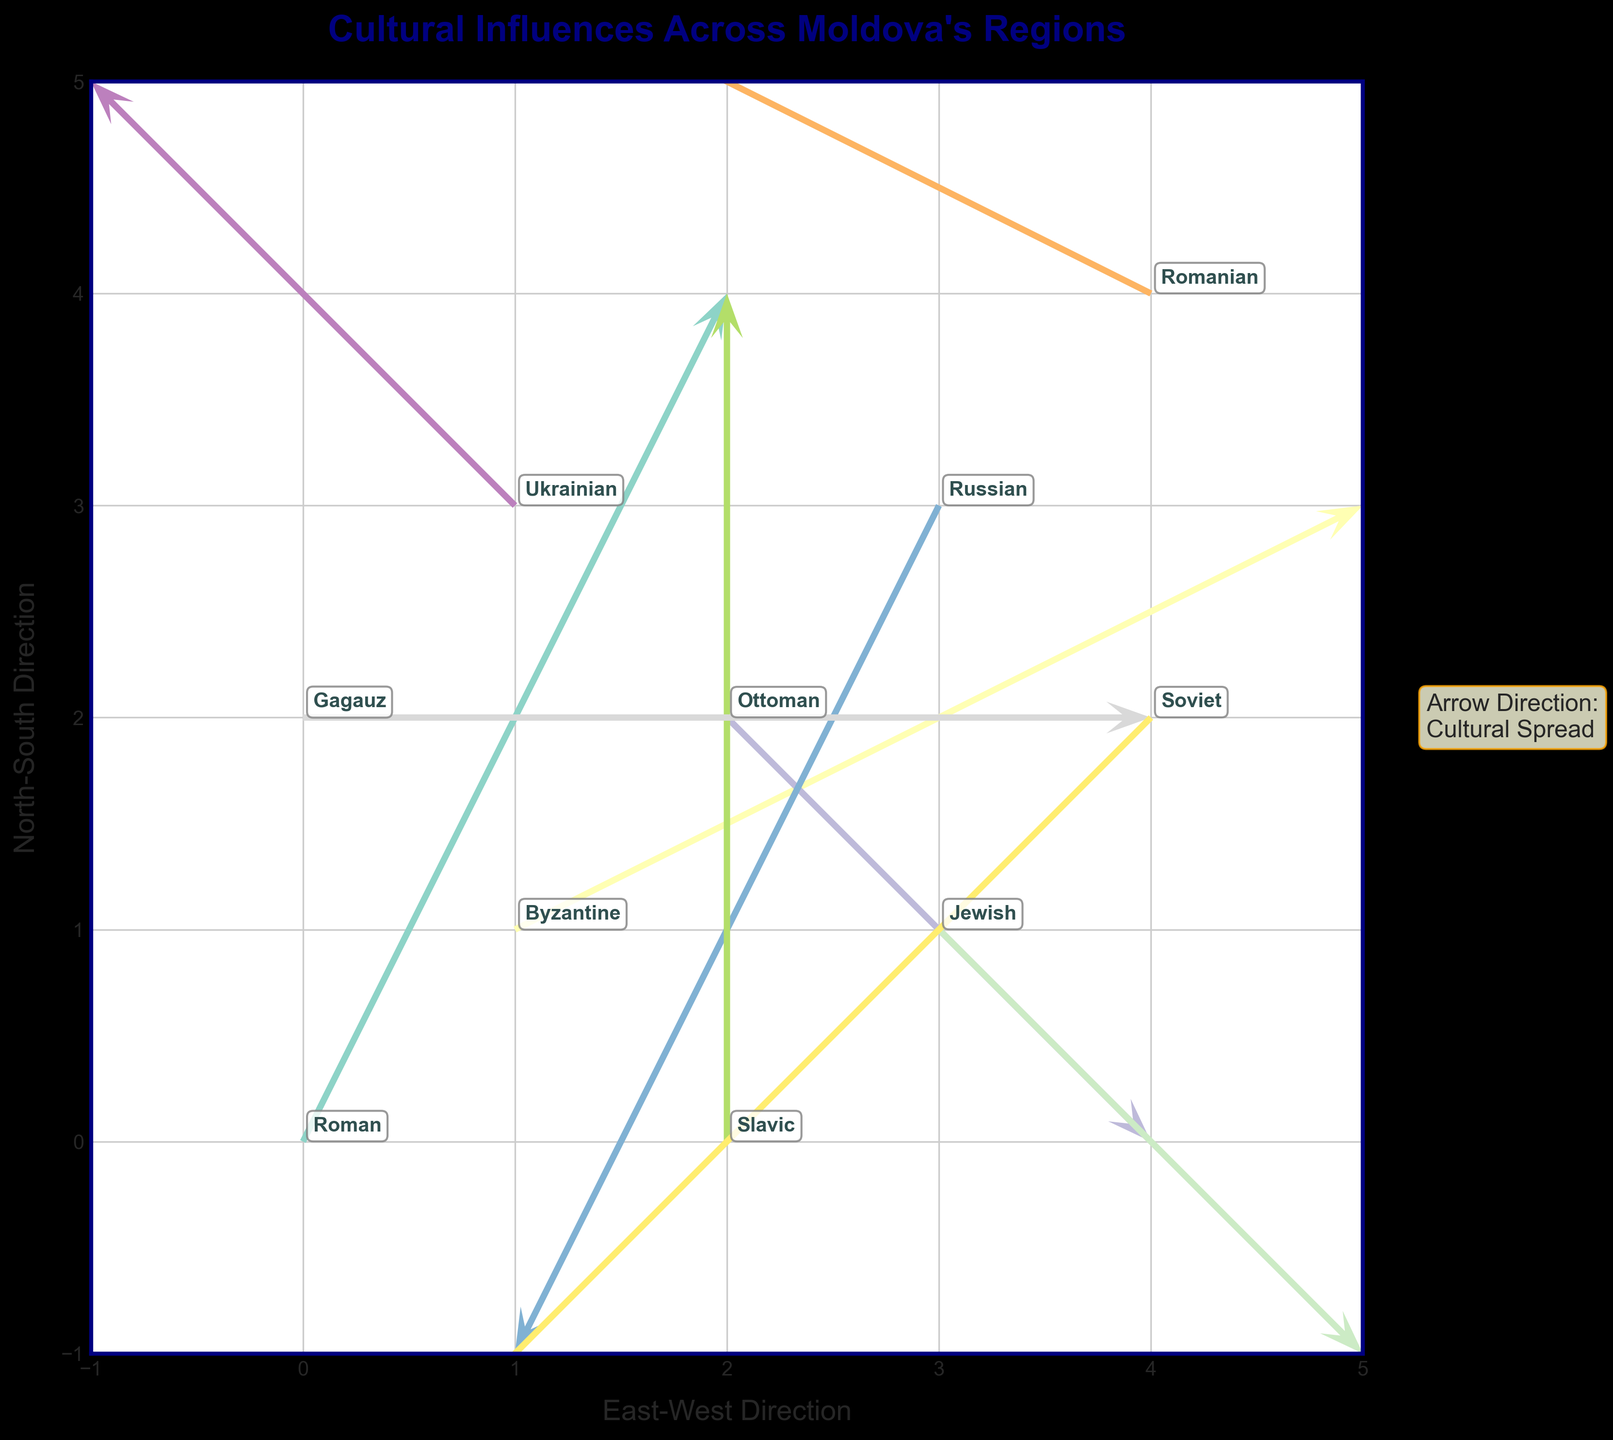What is the most prominent cultural influence at coordinates (0, 0)? The coordinates (0, 0) have a label next to the arrow, and it reads 'Roman'. Therefore, the most prominent cultural influence at these coordinates is the Roman influence.
Answer: Roman In which direction does the Byzantine influence spread from its origin? The Byzantine influence starts at coordinates (1, 1) and the quiver arrow points to the right and slightly upwards, indicating a spread towards the north-east.
Answer: North-East Compare the direction of cultural spread for Ottoman and Russian influences. Which one spreads more towards the south? The Ottoman influence (2, 2) spreads with a downward component (v = -1), while the Russian influence (3, 3) spreads more steeply downward (v = -2). Therefore, Russian influence spreads more towards the south.
Answer: Russian How many arrows in the plot represent cultural influences coming from the north? By looking at the arrows, we identify influences coming from the north if their v-component is positive. The influences that fit this condition are Roman (v=2), Slavic (v=2), and Romanian (+1). Thus, there are 3 arrows representing cultural influences coming from the north.
Answer: 3 Which cultural influence originates at coordinates (4, 4)? At coordinates (4, 4), the label next to the arrow is 'Romanian'. Therefore, the cultural influence originating from these coordinates is Romanian.
Answer: Romanian Which influence has the most horizontal spread (largest absolute value of the u-component)? By comparing the absolute values of the u-components, it is evident that the Soviet influence has the largest horizontal spread with u = -2.
Answer: Soviet Which cultural influence has no horizontal spread (u-component = 0)? The Slavic influence, which originates from coordinates (2, 0), has a u-component of 0, indicating no horizontal spread.
Answer: Slavic Between Gagauz and Ukrainian influences, which one has a larger northward component? The Gagauz influence has a v-component of 0, indicating no upward movement. The Ukrainian influence has a v-component of 1, indicating a larger northward movement.
Answer: Ukrainian Which influence spreads in the south-west direction? The Jewish influence starts at coordinates (3, 1) and the arrow points towards the south-west (1, -1).
Answer: Jewish 